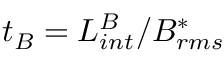<formula> <loc_0><loc_0><loc_500><loc_500>t _ { B } = L _ { i n t } ^ { B } / B _ { r m s } ^ { * }</formula> 